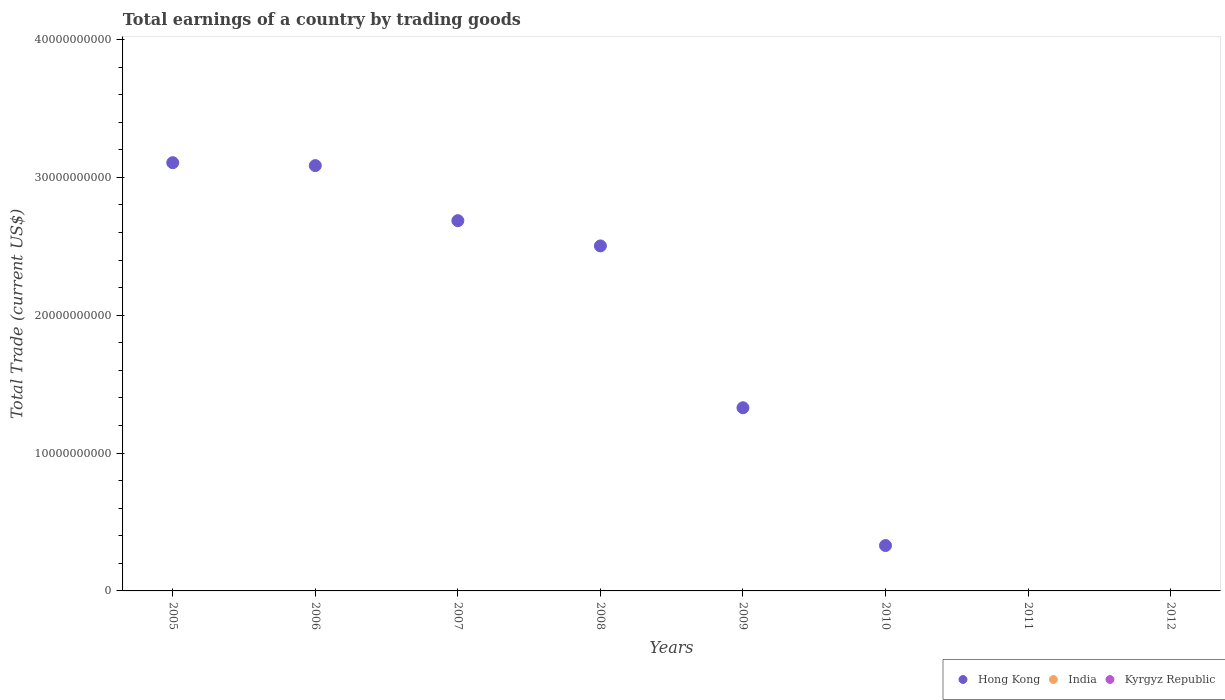How many different coloured dotlines are there?
Provide a succinct answer. 1. Across all years, what is the maximum total earnings in Hong Kong?
Provide a short and direct response. 3.11e+1. Across all years, what is the minimum total earnings in India?
Offer a very short reply. 0. What is the total total earnings in Hong Kong in the graph?
Give a very brief answer. 1.30e+11. What is the difference between the total earnings in Hong Kong in 2009 and that in 2010?
Give a very brief answer. 1.00e+1. What is the average total earnings in India per year?
Provide a short and direct response. 0. What is the ratio of the total earnings in Hong Kong in 2006 to that in 2007?
Provide a succinct answer. 1.15. Is the total earnings in Hong Kong in 2007 less than that in 2008?
Offer a terse response. No. What is the difference between the highest and the second highest total earnings in Hong Kong?
Your answer should be compact. 2.11e+08. In how many years, is the total earnings in India greater than the average total earnings in India taken over all years?
Keep it short and to the point. 0. Is it the case that in every year, the sum of the total earnings in India and total earnings in Hong Kong  is greater than the total earnings in Kyrgyz Republic?
Make the answer very short. No. Is the total earnings in Hong Kong strictly greater than the total earnings in India over the years?
Your response must be concise. Yes. How many dotlines are there?
Provide a short and direct response. 1. How many years are there in the graph?
Your answer should be very brief. 8. What is the difference between two consecutive major ticks on the Y-axis?
Your response must be concise. 1.00e+1. Does the graph contain grids?
Your answer should be very brief. No. Where does the legend appear in the graph?
Provide a succinct answer. Bottom right. How many legend labels are there?
Your answer should be compact. 3. What is the title of the graph?
Provide a short and direct response. Total earnings of a country by trading goods. Does "Nepal" appear as one of the legend labels in the graph?
Give a very brief answer. No. What is the label or title of the Y-axis?
Your response must be concise. Total Trade (current US$). What is the Total Trade (current US$) of Hong Kong in 2005?
Your response must be concise. 3.11e+1. What is the Total Trade (current US$) of India in 2005?
Provide a short and direct response. 0. What is the Total Trade (current US$) in Hong Kong in 2006?
Provide a short and direct response. 3.09e+1. What is the Total Trade (current US$) in Kyrgyz Republic in 2006?
Give a very brief answer. 0. What is the Total Trade (current US$) of Hong Kong in 2007?
Give a very brief answer. 2.69e+1. What is the Total Trade (current US$) in Kyrgyz Republic in 2007?
Your response must be concise. 0. What is the Total Trade (current US$) in Hong Kong in 2008?
Provide a succinct answer. 2.50e+1. What is the Total Trade (current US$) in India in 2008?
Ensure brevity in your answer.  0. What is the Total Trade (current US$) in Kyrgyz Republic in 2008?
Ensure brevity in your answer.  0. What is the Total Trade (current US$) of Hong Kong in 2009?
Your answer should be compact. 1.33e+1. What is the Total Trade (current US$) of India in 2009?
Provide a succinct answer. 0. What is the Total Trade (current US$) in Kyrgyz Republic in 2009?
Keep it short and to the point. 0. What is the Total Trade (current US$) of Hong Kong in 2010?
Ensure brevity in your answer.  3.29e+09. What is the Total Trade (current US$) in India in 2010?
Your answer should be very brief. 0. What is the Total Trade (current US$) of Kyrgyz Republic in 2010?
Provide a short and direct response. 0. What is the Total Trade (current US$) in India in 2012?
Your answer should be compact. 0. Across all years, what is the maximum Total Trade (current US$) in Hong Kong?
Offer a very short reply. 3.11e+1. What is the total Total Trade (current US$) of Hong Kong in the graph?
Offer a terse response. 1.30e+11. What is the total Total Trade (current US$) in India in the graph?
Your response must be concise. 0. What is the difference between the Total Trade (current US$) in Hong Kong in 2005 and that in 2006?
Keep it short and to the point. 2.11e+08. What is the difference between the Total Trade (current US$) in Hong Kong in 2005 and that in 2007?
Ensure brevity in your answer.  4.21e+09. What is the difference between the Total Trade (current US$) in Hong Kong in 2005 and that in 2008?
Give a very brief answer. 6.04e+09. What is the difference between the Total Trade (current US$) of Hong Kong in 2005 and that in 2009?
Offer a terse response. 1.78e+1. What is the difference between the Total Trade (current US$) in Hong Kong in 2005 and that in 2010?
Your answer should be compact. 2.78e+1. What is the difference between the Total Trade (current US$) in Hong Kong in 2006 and that in 2007?
Provide a short and direct response. 4.00e+09. What is the difference between the Total Trade (current US$) of Hong Kong in 2006 and that in 2008?
Offer a terse response. 5.83e+09. What is the difference between the Total Trade (current US$) of Hong Kong in 2006 and that in 2009?
Your answer should be compact. 1.76e+1. What is the difference between the Total Trade (current US$) in Hong Kong in 2006 and that in 2010?
Offer a very short reply. 2.76e+1. What is the difference between the Total Trade (current US$) in Hong Kong in 2007 and that in 2008?
Your answer should be compact. 1.83e+09. What is the difference between the Total Trade (current US$) in Hong Kong in 2007 and that in 2009?
Your response must be concise. 1.36e+1. What is the difference between the Total Trade (current US$) of Hong Kong in 2007 and that in 2010?
Your answer should be compact. 2.36e+1. What is the difference between the Total Trade (current US$) of Hong Kong in 2008 and that in 2009?
Make the answer very short. 1.17e+1. What is the difference between the Total Trade (current US$) in Hong Kong in 2008 and that in 2010?
Your answer should be compact. 2.17e+1. What is the difference between the Total Trade (current US$) in Hong Kong in 2009 and that in 2010?
Ensure brevity in your answer.  1.00e+1. What is the average Total Trade (current US$) in Hong Kong per year?
Offer a very short reply. 1.63e+1. What is the ratio of the Total Trade (current US$) of Hong Kong in 2005 to that in 2006?
Provide a succinct answer. 1.01. What is the ratio of the Total Trade (current US$) of Hong Kong in 2005 to that in 2007?
Ensure brevity in your answer.  1.16. What is the ratio of the Total Trade (current US$) of Hong Kong in 2005 to that in 2008?
Your answer should be very brief. 1.24. What is the ratio of the Total Trade (current US$) of Hong Kong in 2005 to that in 2009?
Offer a very short reply. 2.34. What is the ratio of the Total Trade (current US$) of Hong Kong in 2005 to that in 2010?
Ensure brevity in your answer.  9.44. What is the ratio of the Total Trade (current US$) of Hong Kong in 2006 to that in 2007?
Your answer should be compact. 1.15. What is the ratio of the Total Trade (current US$) of Hong Kong in 2006 to that in 2008?
Give a very brief answer. 1.23. What is the ratio of the Total Trade (current US$) of Hong Kong in 2006 to that in 2009?
Give a very brief answer. 2.32. What is the ratio of the Total Trade (current US$) of Hong Kong in 2006 to that in 2010?
Provide a succinct answer. 9.37. What is the ratio of the Total Trade (current US$) of Hong Kong in 2007 to that in 2008?
Provide a short and direct response. 1.07. What is the ratio of the Total Trade (current US$) of Hong Kong in 2007 to that in 2009?
Your answer should be compact. 2.02. What is the ratio of the Total Trade (current US$) in Hong Kong in 2007 to that in 2010?
Your answer should be compact. 8.16. What is the ratio of the Total Trade (current US$) in Hong Kong in 2008 to that in 2009?
Keep it short and to the point. 1.88. What is the ratio of the Total Trade (current US$) of Hong Kong in 2008 to that in 2010?
Offer a terse response. 7.6. What is the ratio of the Total Trade (current US$) in Hong Kong in 2009 to that in 2010?
Offer a terse response. 4.04. What is the difference between the highest and the second highest Total Trade (current US$) in Hong Kong?
Your answer should be compact. 2.11e+08. What is the difference between the highest and the lowest Total Trade (current US$) of Hong Kong?
Your answer should be very brief. 3.11e+1. 